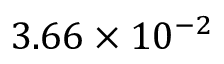Convert formula to latex. <formula><loc_0><loc_0><loc_500><loc_500>3 . 6 6 \times 1 0 ^ { - 2 }</formula> 